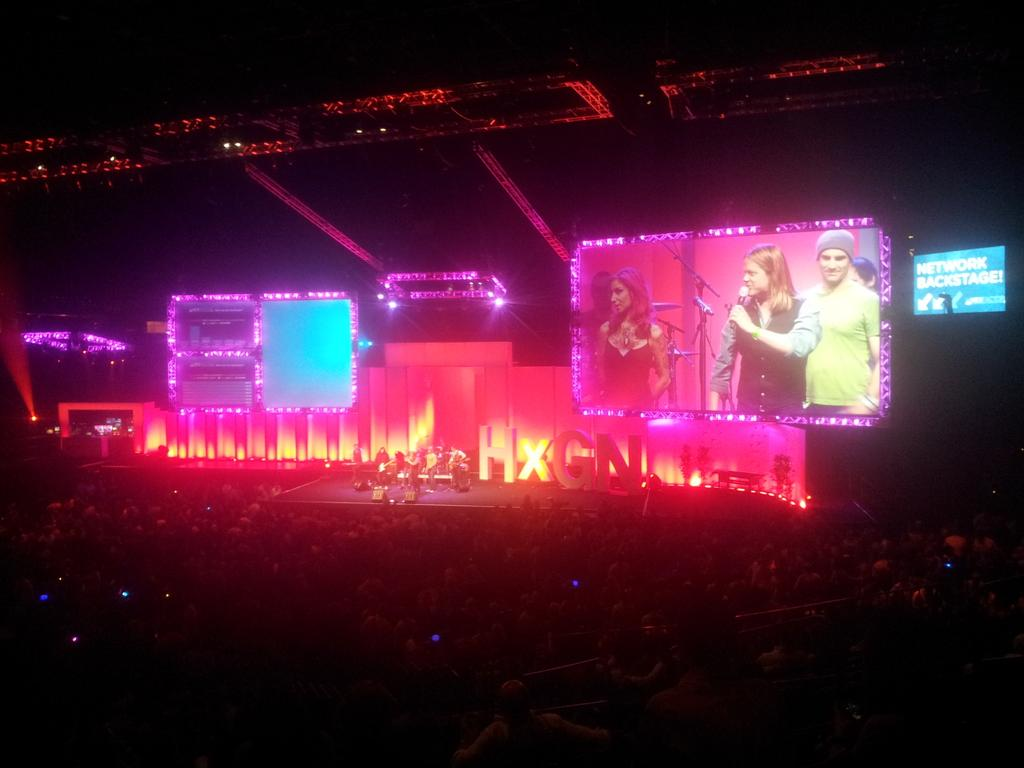What is the main feature in the center of the image? There is a stage in the center of the image. What is happening on the stage? There are people on the stage. What type of visual aids are present in the image? There are screens present in the image. What can be seen at the bottom of the image? There is a crowd at the bottom of the image. What can be seen in the background of the image? There are lights in the background of the image. What type of scent can be detected in the image? There is no information about a scent in the image, so it cannot be determined. How many crows are visible in the image? There are no crows present in the image. 